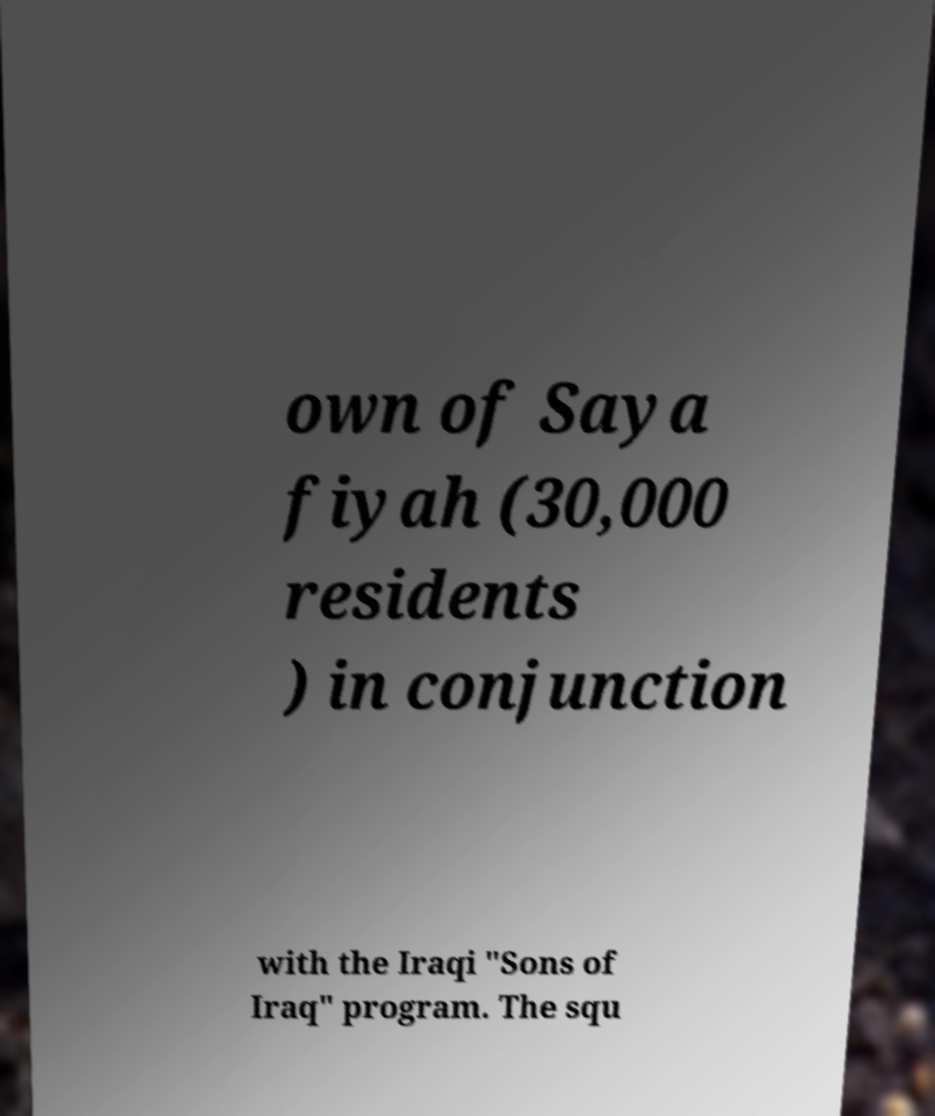Can you read and provide the text displayed in the image?This photo seems to have some interesting text. Can you extract and type it out for me? own of Saya fiyah (30,000 residents ) in conjunction with the Iraqi "Sons of Iraq" program. The squ 